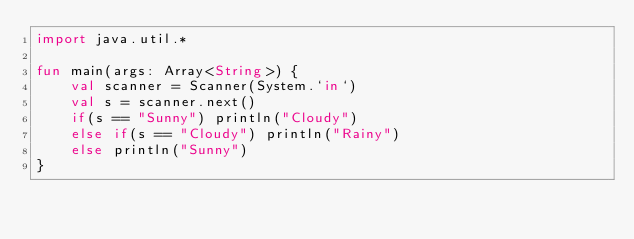Convert code to text. <code><loc_0><loc_0><loc_500><loc_500><_Kotlin_>import java.util.*

fun main(args: Array<String>) {
    val scanner = Scanner(System.`in`)
    val s = scanner.next()
    if(s == "Sunny") println("Cloudy")
    else if(s == "Cloudy") println("Rainy")
    else println("Sunny")
}</code> 